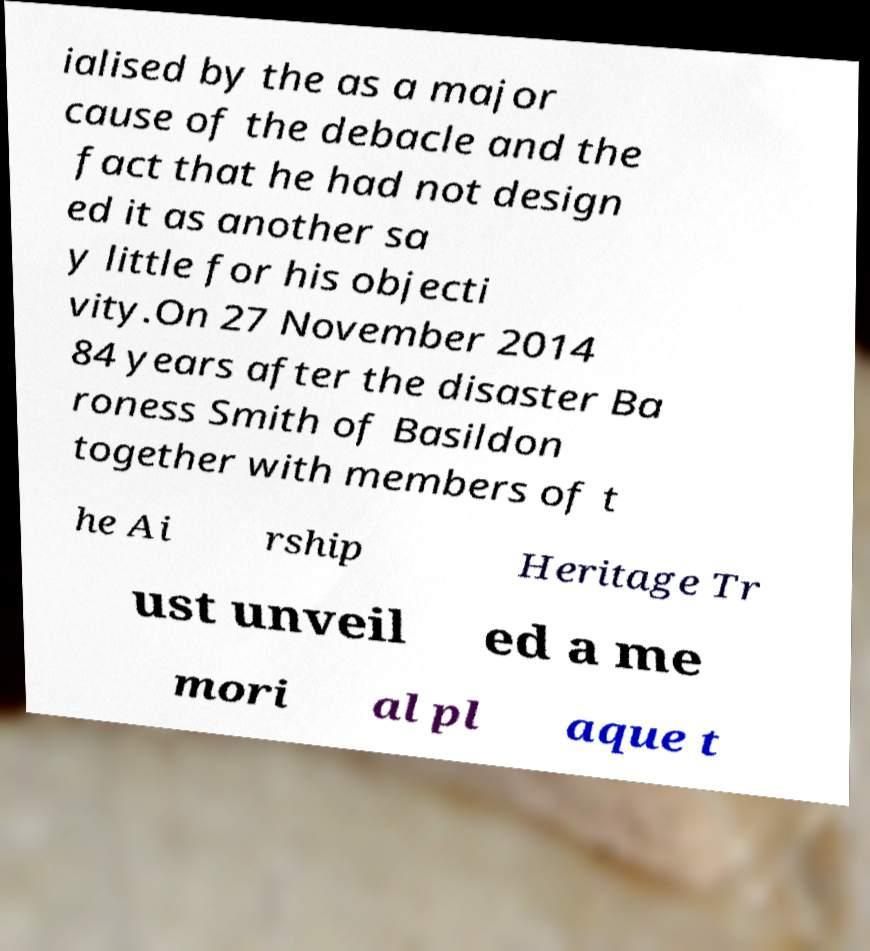Can you accurately transcribe the text from the provided image for me? ialised by the as a major cause of the debacle and the fact that he had not design ed it as another sa y little for his objecti vity.On 27 November 2014 84 years after the disaster Ba roness Smith of Basildon together with members of t he Ai rship Heritage Tr ust unveil ed a me mori al pl aque t 